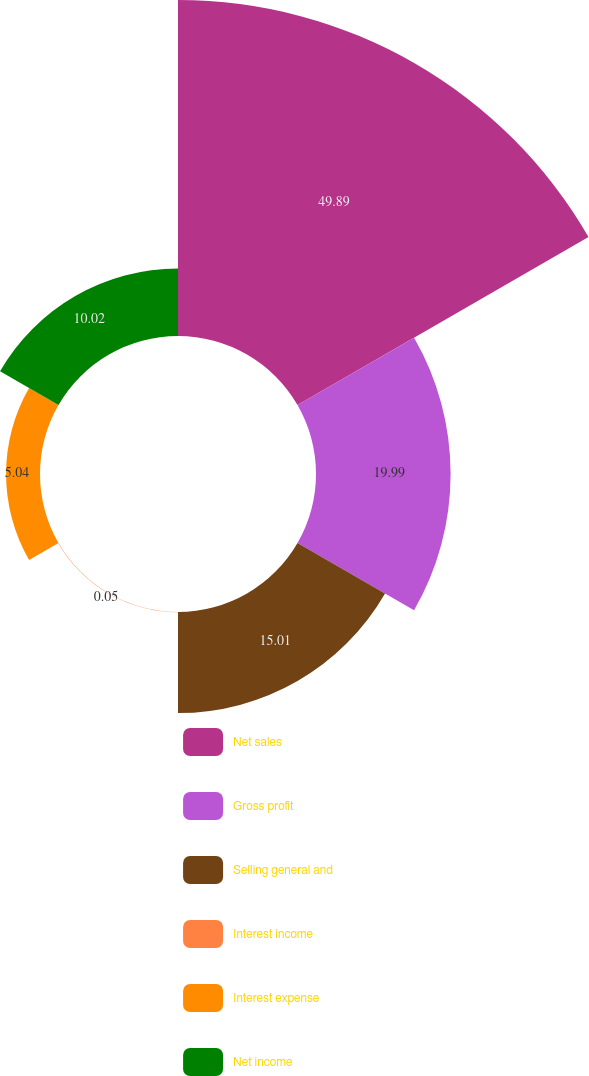<chart> <loc_0><loc_0><loc_500><loc_500><pie_chart><fcel>Net sales<fcel>Gross profit<fcel>Selling general and<fcel>Interest income<fcel>Interest expense<fcel>Net income<nl><fcel>49.9%<fcel>19.99%<fcel>15.01%<fcel>0.05%<fcel>5.04%<fcel>10.02%<nl></chart> 